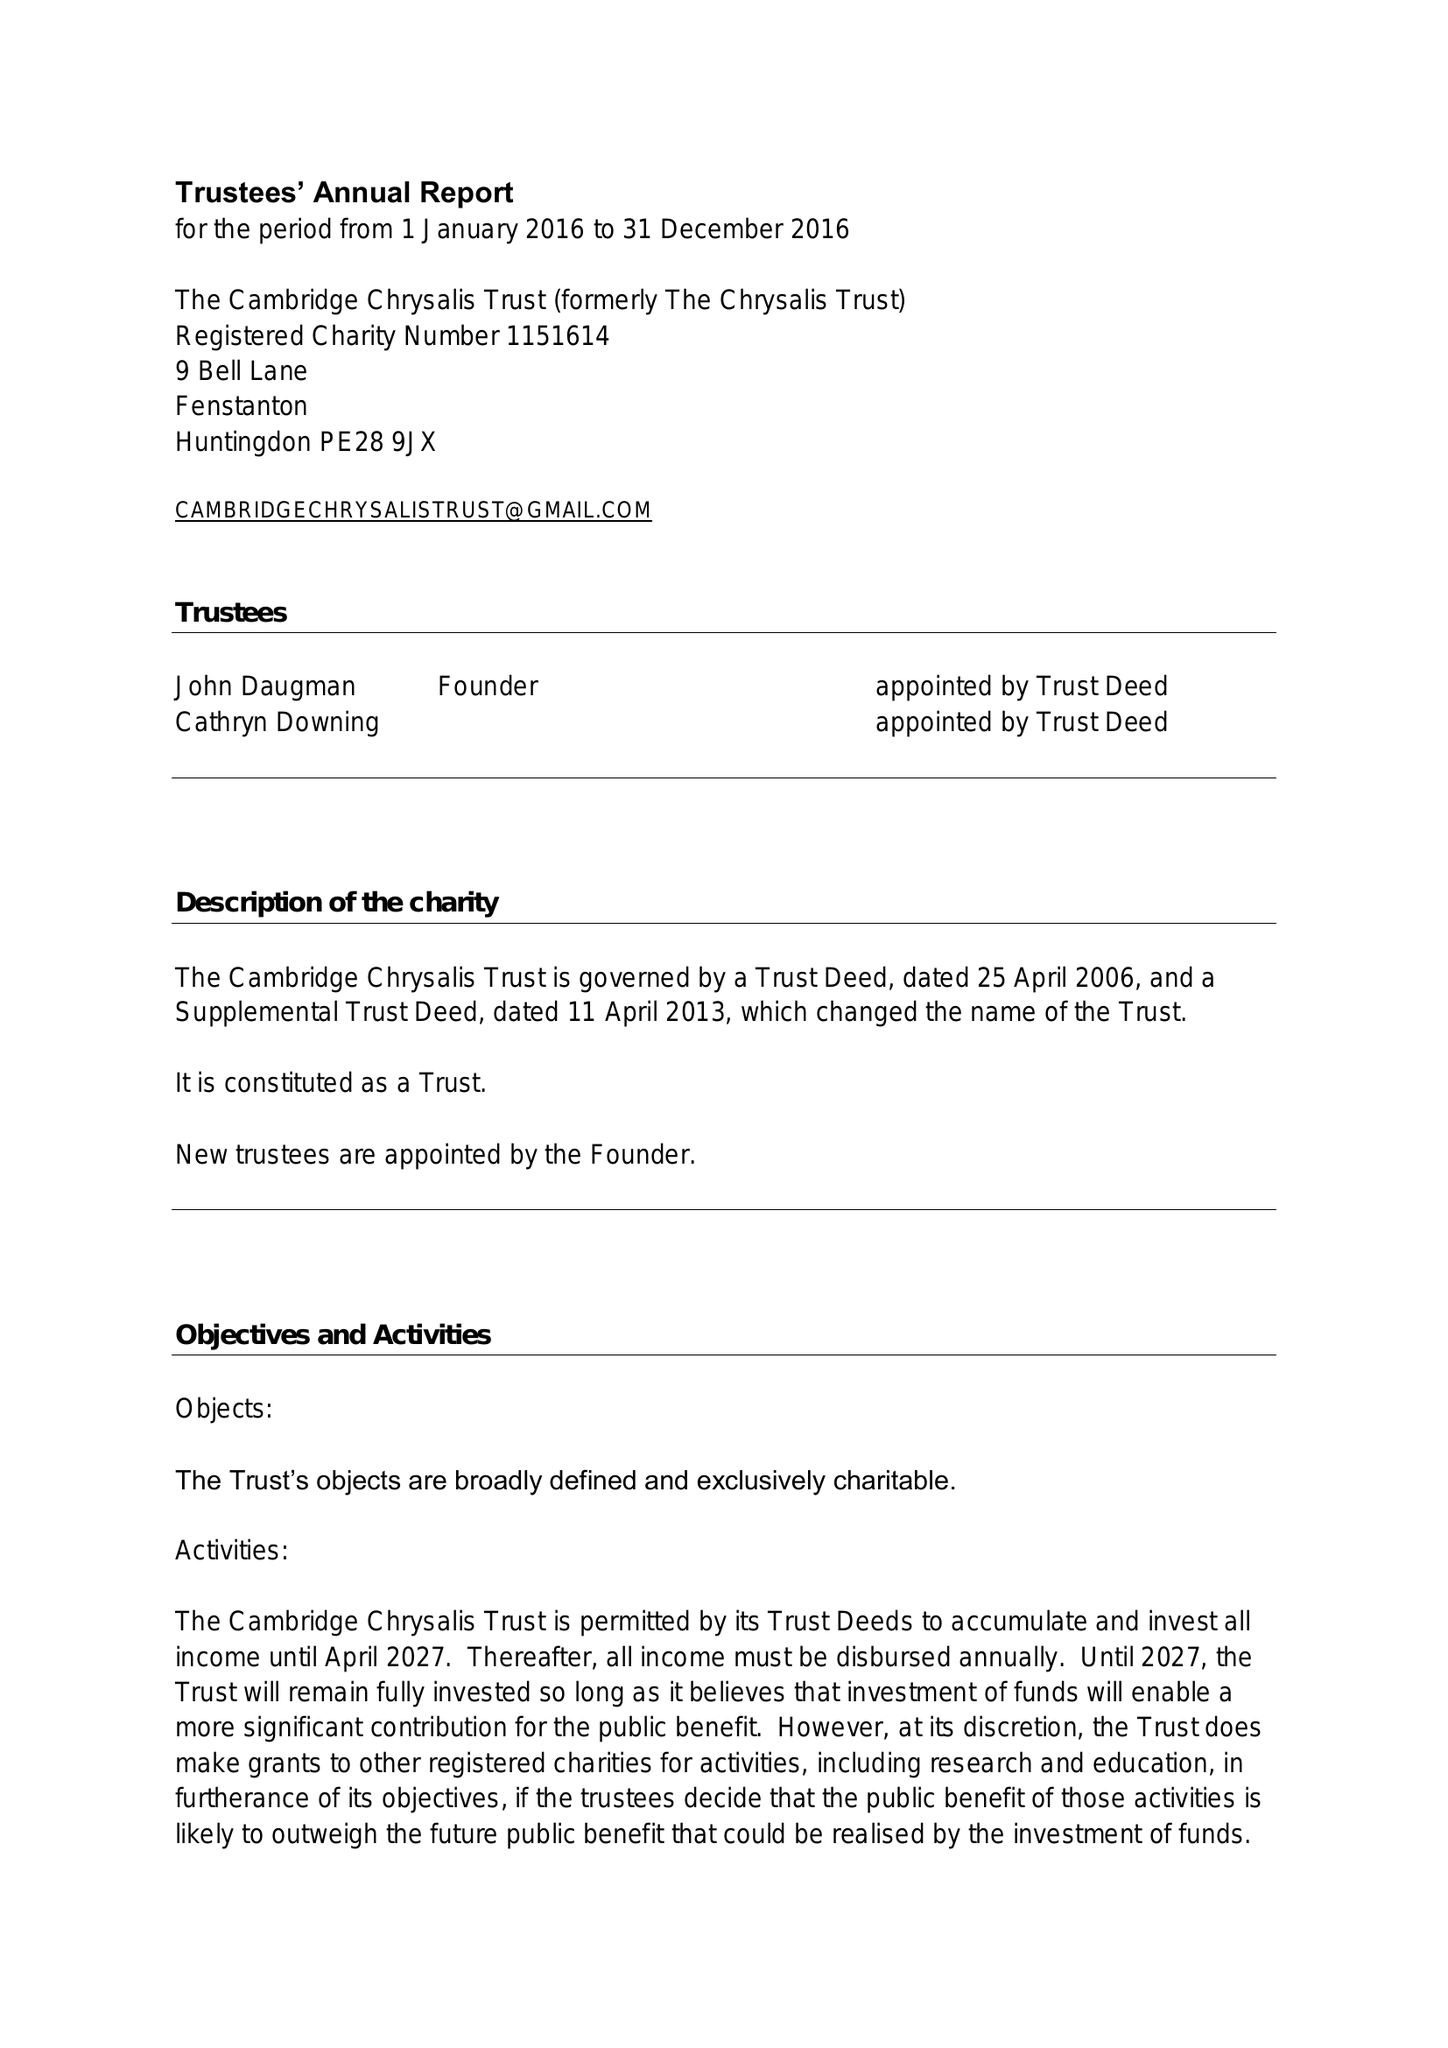What is the value for the address__street_line?
Answer the question using a single word or phrase. 9 BELL LANE 